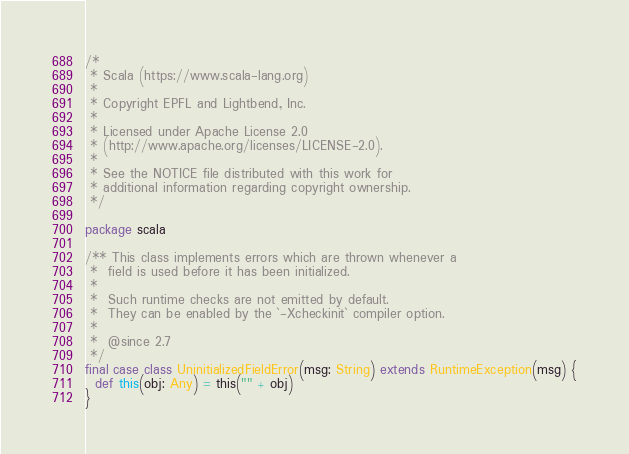<code> <loc_0><loc_0><loc_500><loc_500><_Scala_>/*
 * Scala (https://www.scala-lang.org)
 *
 * Copyright EPFL and Lightbend, Inc.
 *
 * Licensed under Apache License 2.0
 * (http://www.apache.org/licenses/LICENSE-2.0).
 *
 * See the NOTICE file distributed with this work for
 * additional information regarding copyright ownership.
 */

package scala

/** This class implements errors which are thrown whenever a
 *  field is used before it has been initialized.
 *
 *  Such runtime checks are not emitted by default.
 *  They can be enabled by the `-Xcheckinit` compiler option.
 *
 *  @since 2.7
 */
final case class UninitializedFieldError(msg: String) extends RuntimeException(msg) {
  def this(obj: Any) = this("" + obj)
}
</code> 